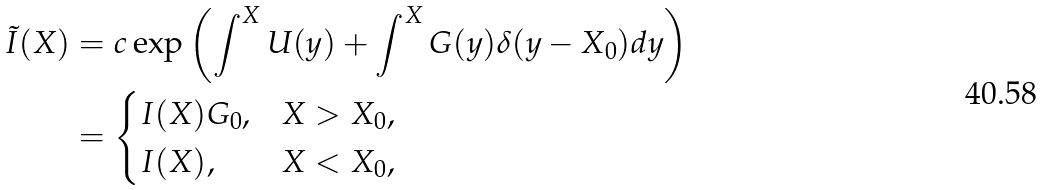<formula> <loc_0><loc_0><loc_500><loc_500>\tilde { I } ( X ) & = c \exp \left ( \int ^ { X } U ( y ) + \int ^ { X } G ( y ) \delta ( y - X _ { 0 } ) d y \right ) \\ & = \begin{cases} I ( X ) G _ { 0 } , & X > X _ { 0 } , \\ I ( X ) , & X < X _ { 0 } , \end{cases}</formula> 